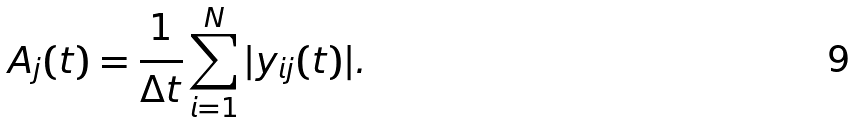<formula> <loc_0><loc_0><loc_500><loc_500>A _ { j } ( t ) = \frac { 1 } { \Delta t } \sum _ { i = 1 } ^ { N } | y _ { i j } ( t ) | .</formula> 